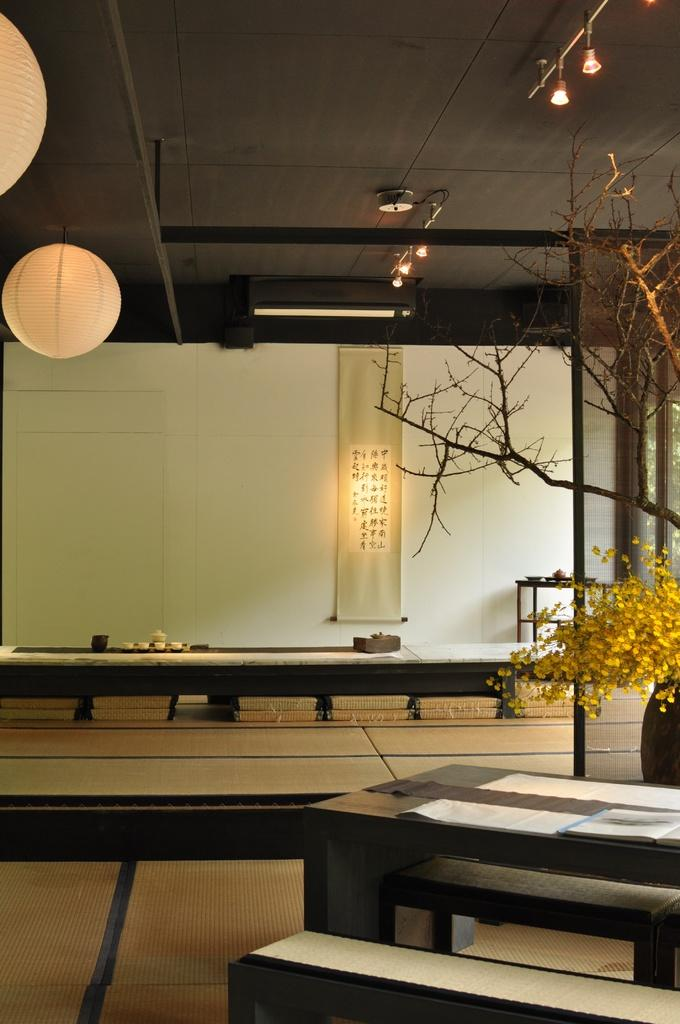What can be found on the tables in the image? There are objects on the tables, including a flower vase, tree stems, paper lanterns, and other objects. Can you describe the decorative item on the table? There is a flower vase on the table. What type of plant is present on the table? Tree stems are present on the table. What type of lighting is visible in the image? Lights are present in the image. What type of seating is available in the image? There are benches in the image. What type of banner is present in the image? There is a fabric banner with text in the image. How many boys are playing with cars in the image? There are no boys or cars present in the image. What type of minister is depicted in the image? There is no minister depicted in the image. 